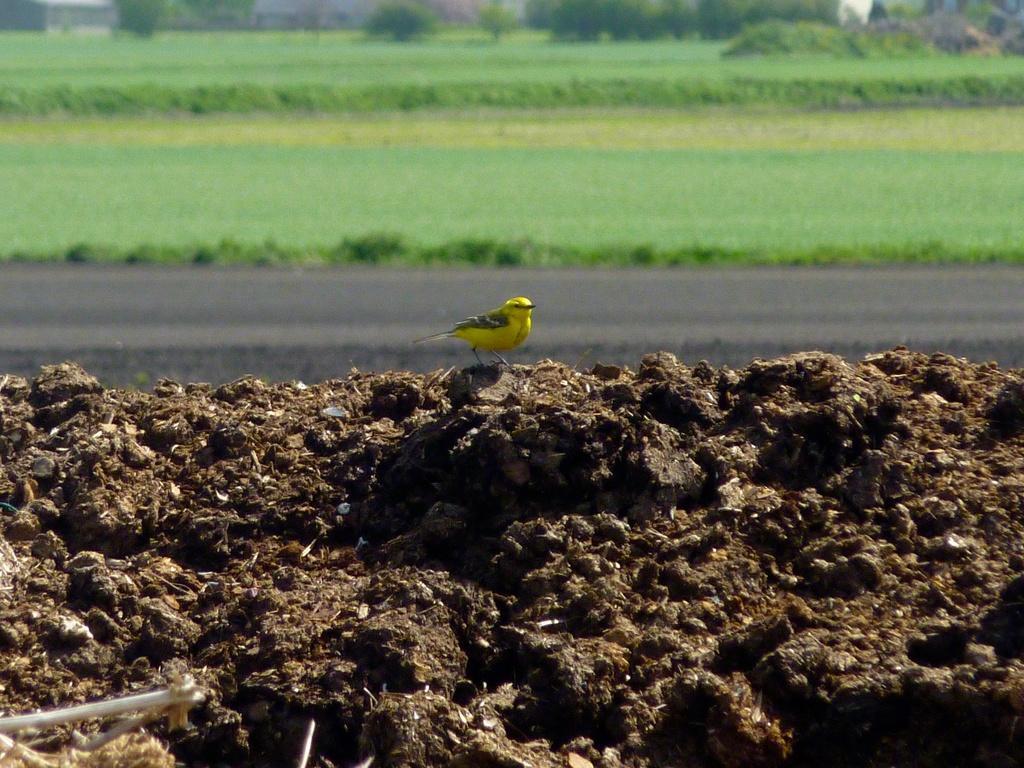In one or two sentences, can you explain what this image depicts? In this image I can see a bird which is yellow and black in color on the ground. In the background I can see some grass and few trees. 